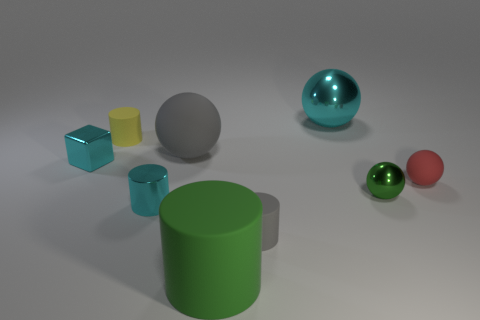Subtract all tiny cyan shiny cylinders. How many cylinders are left? 3 Subtract all cubes. How many objects are left? 8 Add 1 red balls. How many objects exist? 10 Subtract all gray cylinders. How many cylinders are left? 3 Subtract 1 cylinders. How many cylinders are left? 3 Add 5 tiny gray rubber objects. How many tiny gray rubber objects exist? 6 Subtract 0 red cubes. How many objects are left? 9 Subtract all green spheres. Subtract all gray cylinders. How many spheres are left? 3 Subtract all cyan blocks. How many cyan cylinders are left? 1 Subtract all small yellow cylinders. Subtract all green things. How many objects are left? 6 